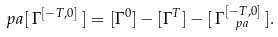Convert formula to latex. <formula><loc_0><loc_0><loc_500><loc_500>\ p a [ \, \Gamma ^ { [ - T , 0 ] } \, ] = [ \Gamma ^ { 0 } ] - [ \Gamma ^ { T } ] - [ \, \Gamma ^ { [ - T , 0 ] } _ { \ p a } \, ] .</formula> 